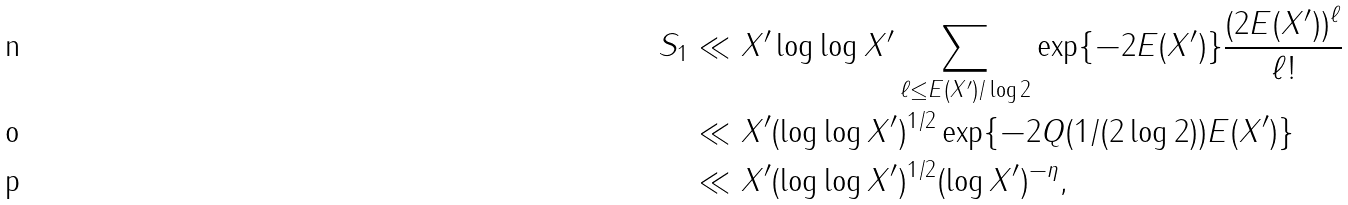Convert formula to latex. <formula><loc_0><loc_0><loc_500><loc_500>S _ { 1 } & \ll X ^ { \prime } \log \log X ^ { \prime } \sum _ { \ell \leq E ( X ^ { \prime } ) / \log 2 } \exp \{ - 2 E ( X ^ { \prime } ) \} \frac { ( 2 E ( X ^ { \prime } ) ) ^ { \ell } } { \ell ! } \\ & \ll X ^ { \prime } ( \log \log X ^ { \prime } ) ^ { 1 / 2 } \exp \{ - 2 Q ( 1 / ( 2 \log 2 ) ) E ( X ^ { \prime } ) \} \\ & \ll X ^ { \prime } ( \log \log X ^ { \prime } ) ^ { 1 / 2 } ( \log X ^ { \prime } ) ^ { - \eta } ,</formula> 